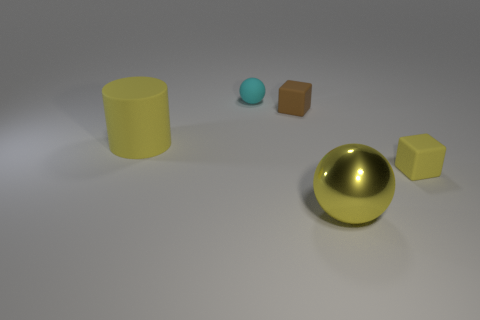What number of other objects are there of the same size as the yellow matte cylinder?
Ensure brevity in your answer.  1. Is there a green shiny sphere that has the same size as the brown cube?
Keep it short and to the point. No. Do the block that is left of the tiny yellow thing and the big sphere have the same color?
Give a very brief answer. No. How many objects are big brown objects or yellow matte cubes?
Your response must be concise. 1. There is a yellow object that is left of the metallic sphere; is its size the same as the big metallic thing?
Keep it short and to the point. Yes. There is a yellow thing that is to the left of the small yellow block and behind the yellow metallic sphere; what size is it?
Make the answer very short. Large. How many other objects are the same shape as the brown rubber object?
Your answer should be very brief. 1. How many other objects are the same material as the large ball?
Keep it short and to the point. 0. There is another object that is the same shape as the small cyan matte thing; what size is it?
Ensure brevity in your answer.  Large. Does the big rubber cylinder have the same color as the big shiny ball?
Your response must be concise. Yes. 